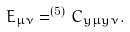<formula> <loc_0><loc_0><loc_500><loc_500>E _ { \mu \nu } = ^ { ( 5 ) } C _ { y \mu y \nu } .</formula> 